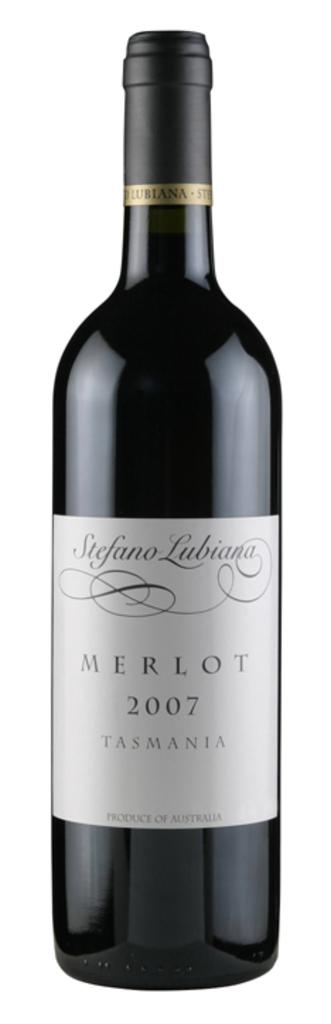<image>
Give a short and clear explanation of the subsequent image. A 2007 bottle of Merlot sports a silver-gray label with a swirling design. 